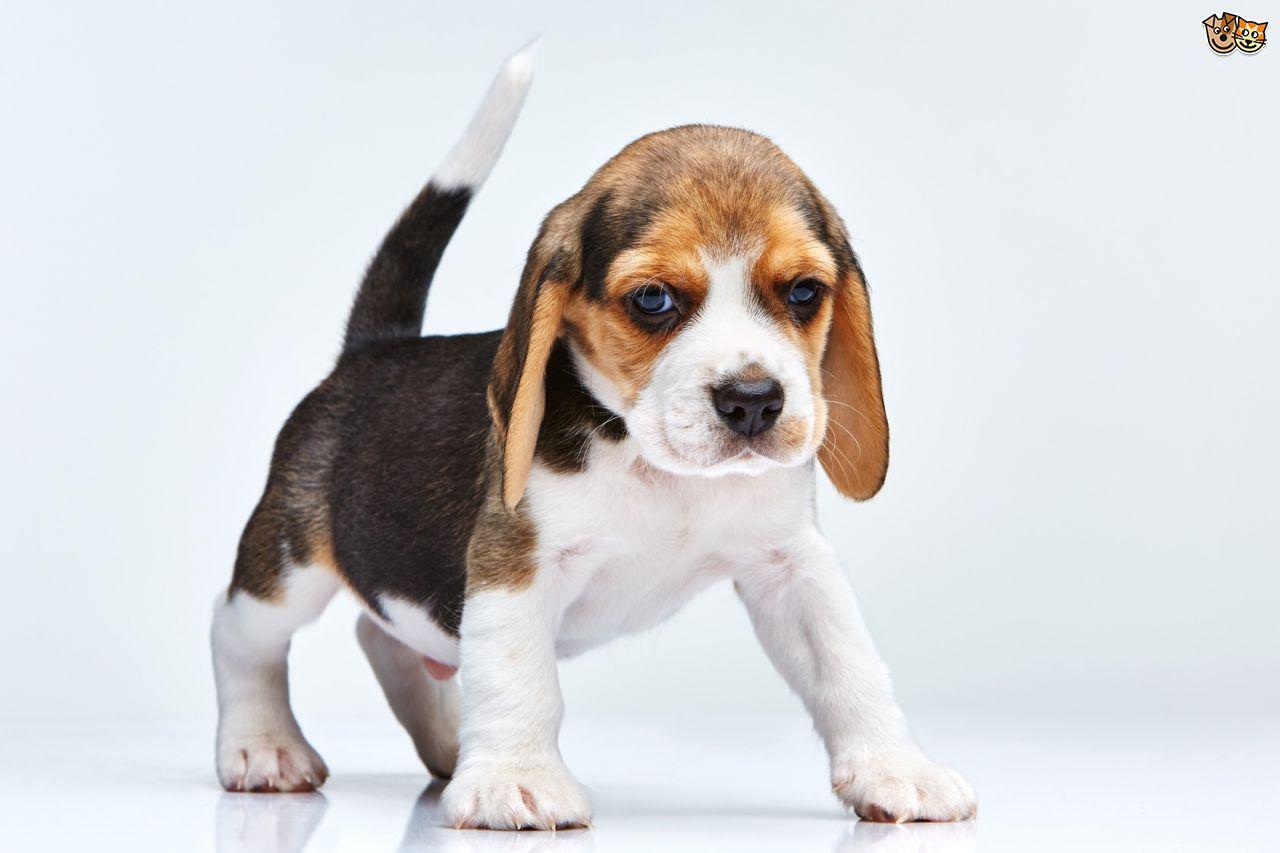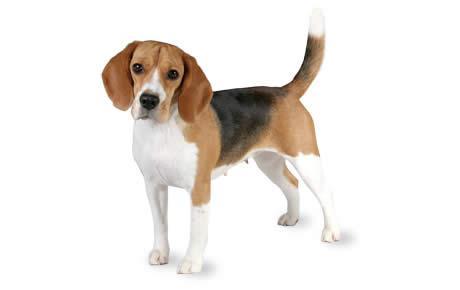The first image is the image on the left, the second image is the image on the right. Examine the images to the left and right. Is the description "A single dog is standing on all fours in the image on the left." accurate? Answer yes or no. Yes. The first image is the image on the left, the second image is the image on the right. Analyze the images presented: Is the assertion "Each image contains exactly one beagle, and each dog is in approximately the same pose." valid? Answer yes or no. Yes. 